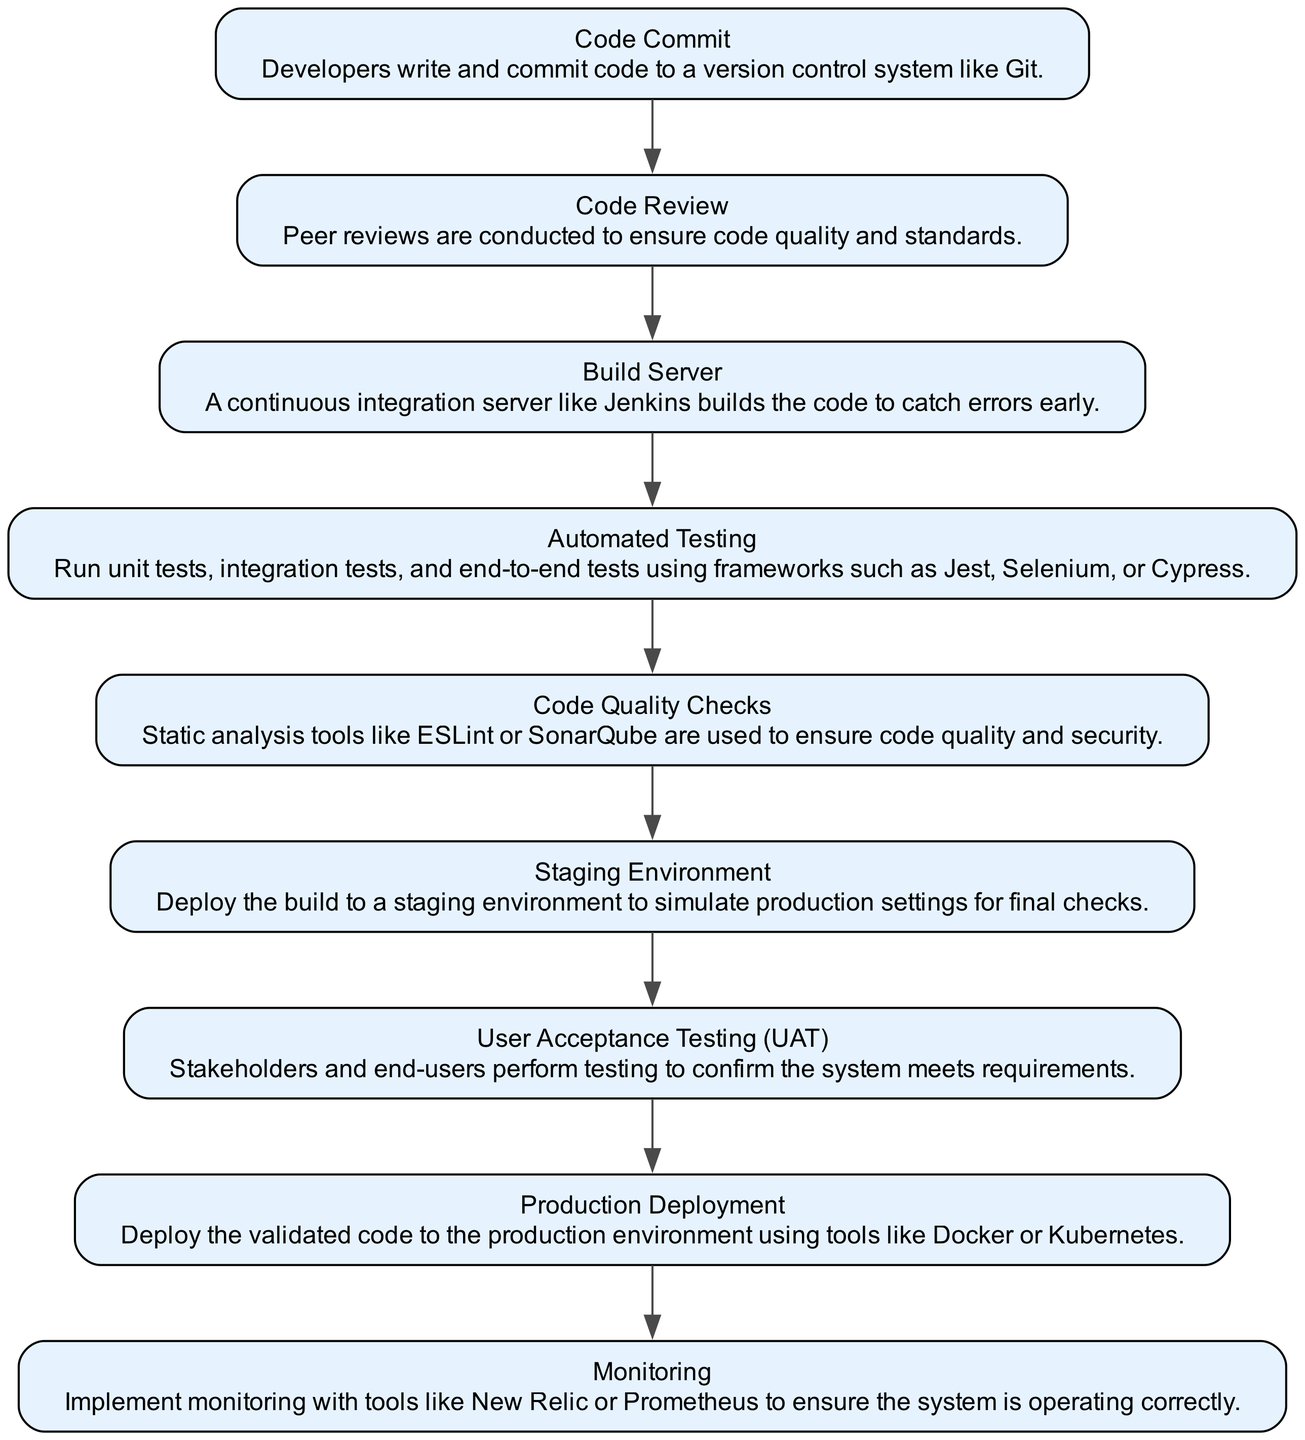What is the first step in the website deployment pipeline? The first step in the diagram is labeled "Code Commit," which indicates that developers write and commit code to a version control system like Git.
Answer: Code Commit How many nodes are present in the flow chart? By counting each of the elements listed, we can find that there are 9 nodes representing various stages in the website deployment pipeline.
Answer: 9 Which node follows "Automated Testing"? The node that follows "Automated Testing" in the flow chart is "Code Quality Checks," indicating that this step occurs after tests are run to ensure quality.
Answer: Code Quality Checks What is the final step before production deployment? The step just before production deployment is "User Acceptance Testing (UAT)," which is when stakeholders confirm that the system meets requirements.
Answer: User Acceptance Testing What is depicted as a key function of the "Monitoring" step? The "Monitoring" step involves implementing tools like New Relic or Prometheus to ensure that the system operates correctly after deployment.
Answer: Implement monitoring How do "Code Review" and "Automated Testing" relate in the pipeline? "Code Review" occurs after "Code Commit" and before "Automated Testing," indicating a sequence where code must be reviewed for quality prior to testing.
Answer: Sequential relationship What tools are mentioned for "Production Deployment"? The tools specified for the "Production Deployment" process are Docker and Kubernetes, which are typically used for container orchestration.
Answer: Docker and Kubernetes Which step validates the deployment before it goes live? The "User Acceptance Testing (UAT)" step is critical as it involves end-users confirming that the system meets the stated requirements before going live.
Answer: User Acceptance Testing After "Code Quality Checks," what is the next node? The process continues from "Code Quality Checks" to "Staging Environment," where the build is deployed for final checks before production.
Answer: Staging Environment 